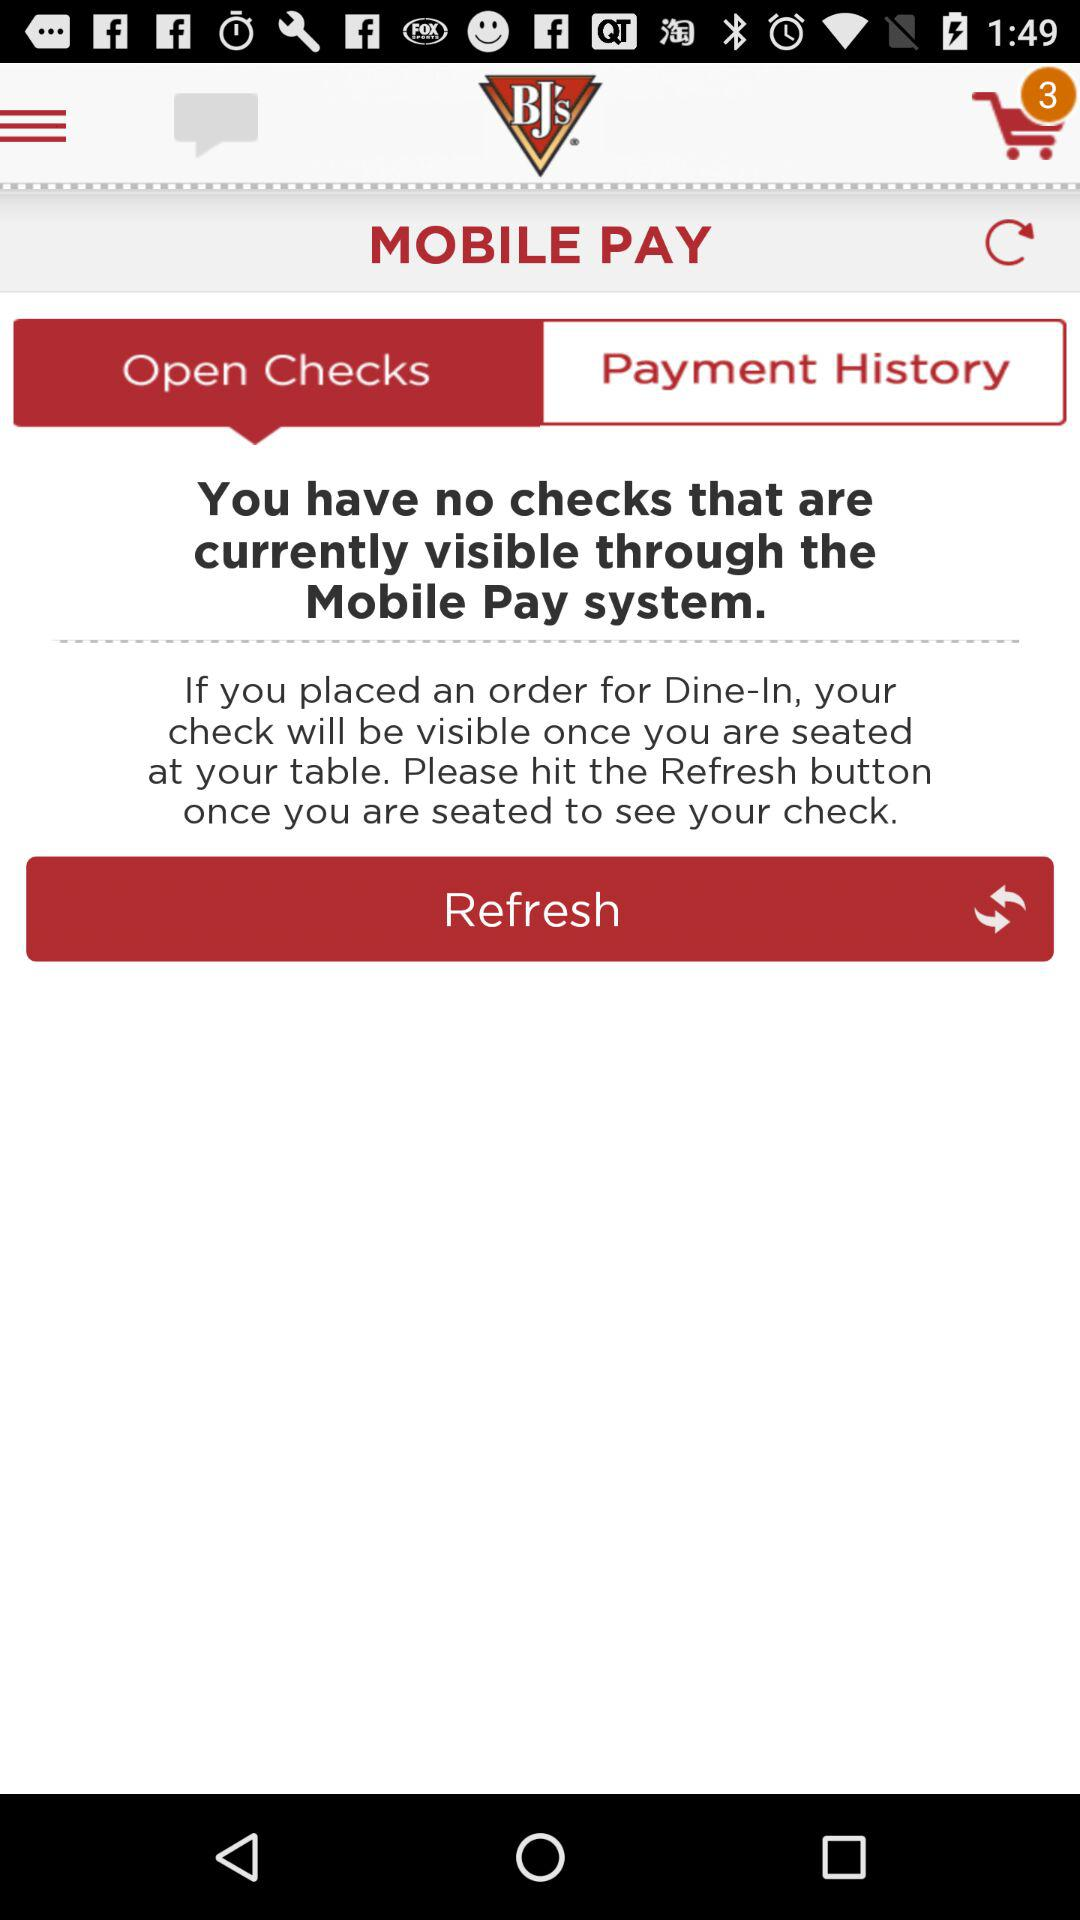Which option is selected? The selected option is "Open Checks". 